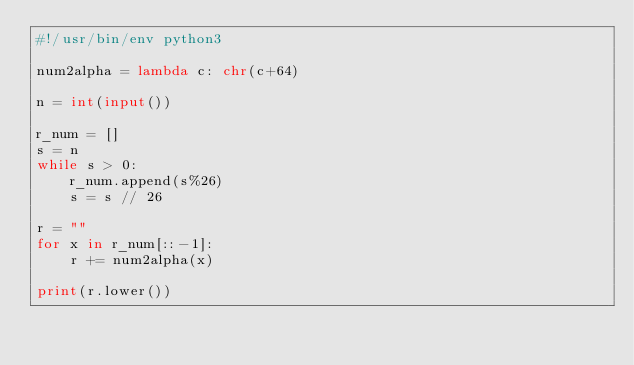Convert code to text. <code><loc_0><loc_0><loc_500><loc_500><_Python_>#!/usr/bin/env python3

num2alpha = lambda c: chr(c+64)

n = int(input())

r_num = []
s = n
while s > 0:
    r_num.append(s%26)
    s = s // 26

r = ""
for x in r_num[::-1]:
    r += num2alpha(x)

print(r.lower())</code> 